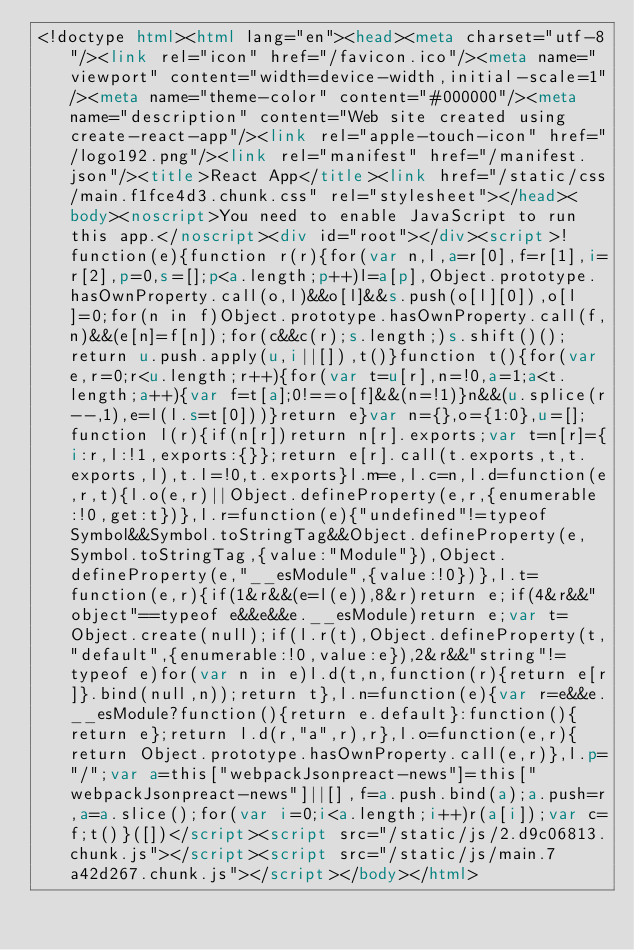<code> <loc_0><loc_0><loc_500><loc_500><_HTML_><!doctype html><html lang="en"><head><meta charset="utf-8"/><link rel="icon" href="/favicon.ico"/><meta name="viewport" content="width=device-width,initial-scale=1"/><meta name="theme-color" content="#000000"/><meta name="description" content="Web site created using create-react-app"/><link rel="apple-touch-icon" href="/logo192.png"/><link rel="manifest" href="/manifest.json"/><title>React App</title><link href="/static/css/main.f1fce4d3.chunk.css" rel="stylesheet"></head><body><noscript>You need to enable JavaScript to run this app.</noscript><div id="root"></div><script>!function(e){function r(r){for(var n,l,a=r[0],f=r[1],i=r[2],p=0,s=[];p<a.length;p++)l=a[p],Object.prototype.hasOwnProperty.call(o,l)&&o[l]&&s.push(o[l][0]),o[l]=0;for(n in f)Object.prototype.hasOwnProperty.call(f,n)&&(e[n]=f[n]);for(c&&c(r);s.length;)s.shift()();return u.push.apply(u,i||[]),t()}function t(){for(var e,r=0;r<u.length;r++){for(var t=u[r],n=!0,a=1;a<t.length;a++){var f=t[a];0!==o[f]&&(n=!1)}n&&(u.splice(r--,1),e=l(l.s=t[0]))}return e}var n={},o={1:0},u=[];function l(r){if(n[r])return n[r].exports;var t=n[r]={i:r,l:!1,exports:{}};return e[r].call(t.exports,t,t.exports,l),t.l=!0,t.exports}l.m=e,l.c=n,l.d=function(e,r,t){l.o(e,r)||Object.defineProperty(e,r,{enumerable:!0,get:t})},l.r=function(e){"undefined"!=typeof Symbol&&Symbol.toStringTag&&Object.defineProperty(e,Symbol.toStringTag,{value:"Module"}),Object.defineProperty(e,"__esModule",{value:!0})},l.t=function(e,r){if(1&r&&(e=l(e)),8&r)return e;if(4&r&&"object"==typeof e&&e&&e.__esModule)return e;var t=Object.create(null);if(l.r(t),Object.defineProperty(t,"default",{enumerable:!0,value:e}),2&r&&"string"!=typeof e)for(var n in e)l.d(t,n,function(r){return e[r]}.bind(null,n));return t},l.n=function(e){var r=e&&e.__esModule?function(){return e.default}:function(){return e};return l.d(r,"a",r),r},l.o=function(e,r){return Object.prototype.hasOwnProperty.call(e,r)},l.p="/";var a=this["webpackJsonpreact-news"]=this["webpackJsonpreact-news"]||[],f=a.push.bind(a);a.push=r,a=a.slice();for(var i=0;i<a.length;i++)r(a[i]);var c=f;t()}([])</script><script src="/static/js/2.d9c06813.chunk.js"></script><script src="/static/js/main.7a42d267.chunk.js"></script></body></html></code> 